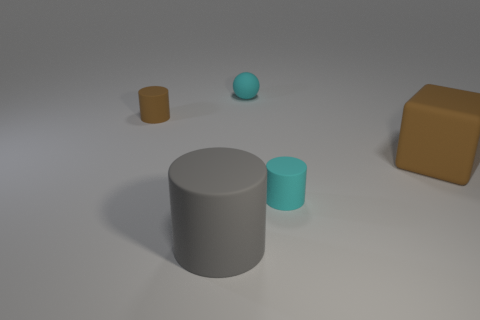Add 5 big yellow matte cubes. How many objects exist? 10 Subtract all blocks. How many objects are left? 4 Add 3 matte spheres. How many matte spheres exist? 4 Subtract 1 brown cylinders. How many objects are left? 4 Subtract all spheres. Subtract all cyan rubber spheres. How many objects are left? 3 Add 2 large blocks. How many large blocks are left? 3 